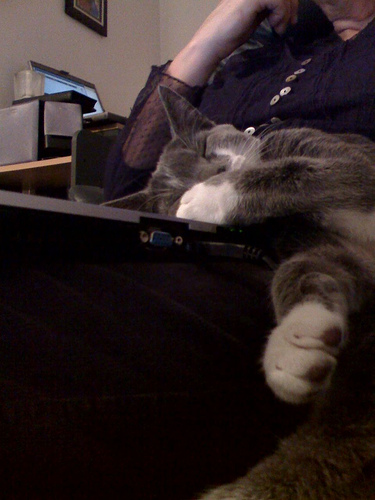<image>What brand is the monitor in the back of the cat? I am not sure about the brand of the monitor in the back of the cat. It could be Dell, HP, or Acer. What brand is the monitor in the back of the cat? I am unsure of the brand of the monitor in the back of the cat. It could be either Dell, HP, or Acer. 